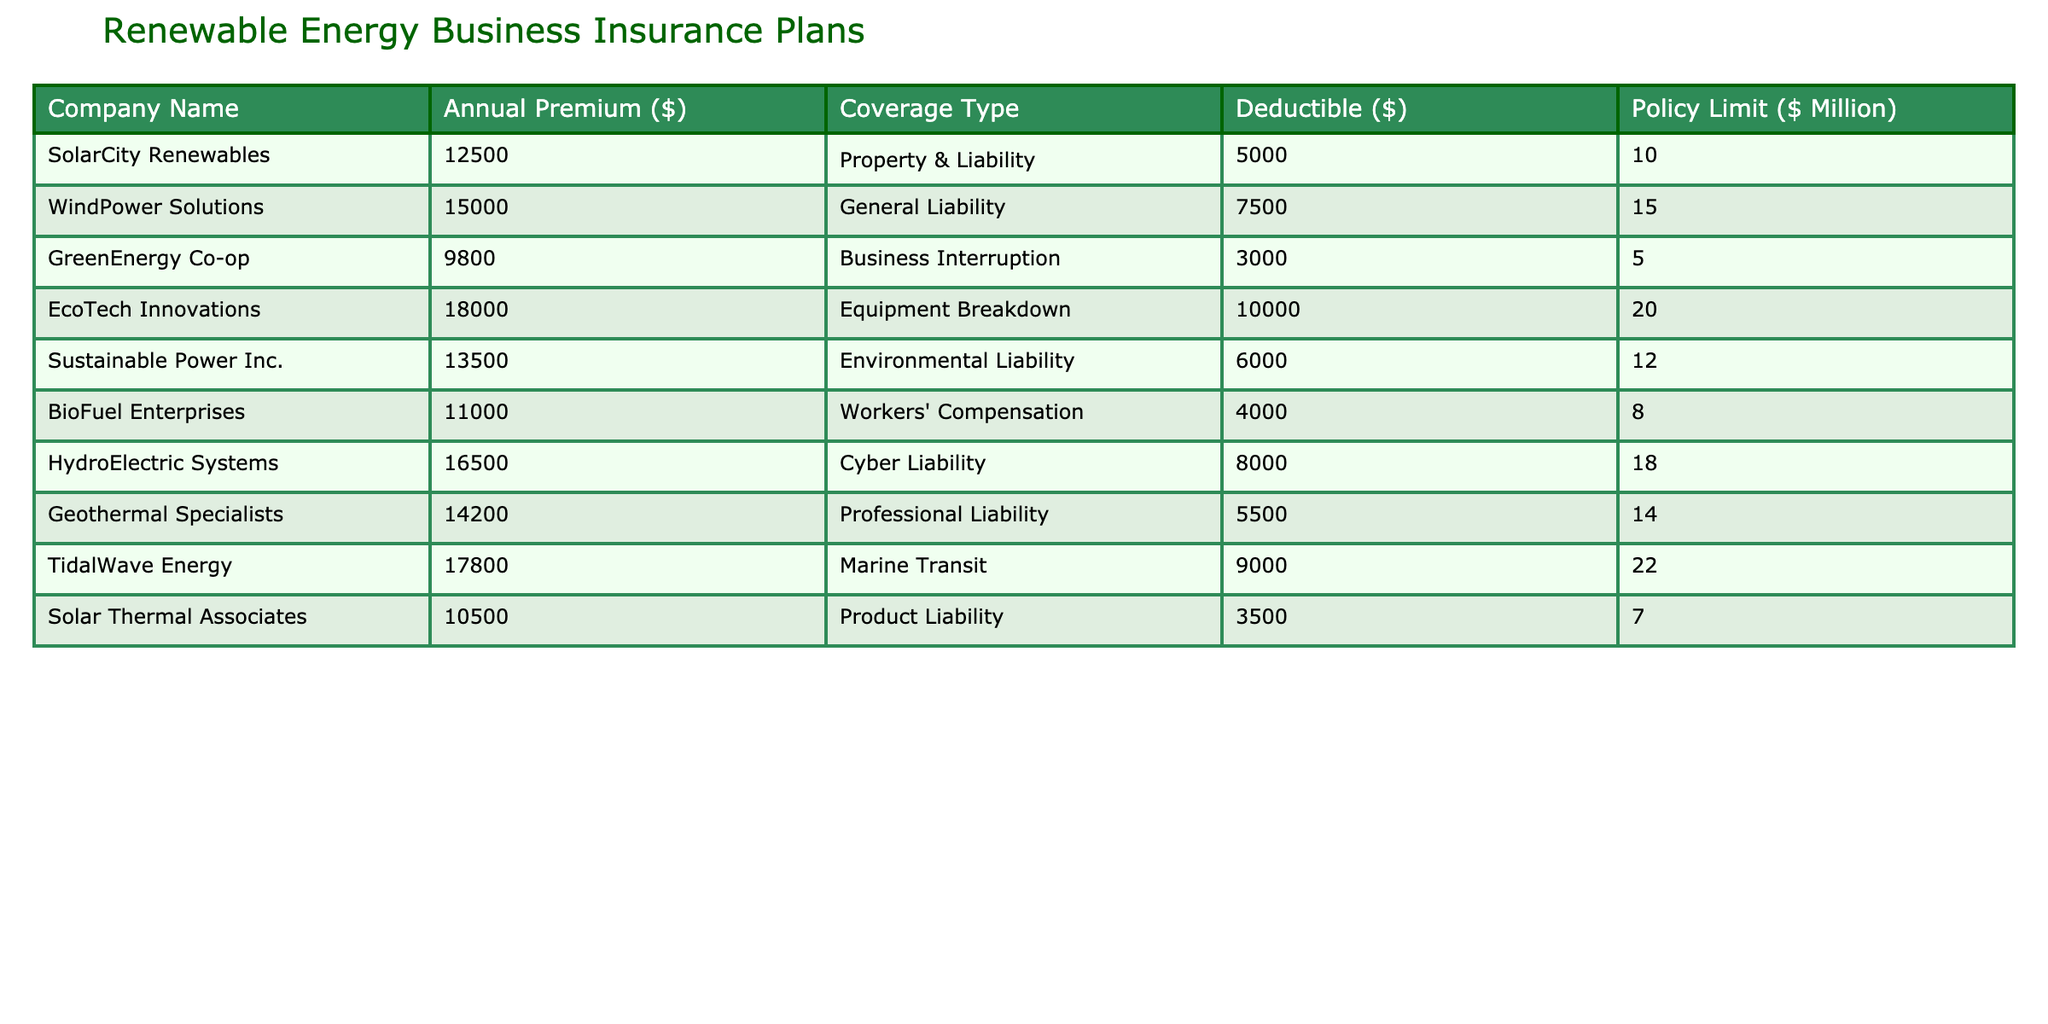What is the highest annual premium in the table? The highest annual premium can be found by scanning the "Annual Premium ($)" column. The value of $18,000 from EcoTech Innovations is the largest.
Answer: 18000 Which company has the lowest deductible? By inspecting the "Deductible ($)" column, the lowest deductible of $3,000 is assigned to GreenEnergy Co-op.
Answer: GreenEnergy Co-op What is the total policy limit of all the companies? Summing the "Policy Limit ($ Million)" for each company: 10 + 15 + 5 + 20 + 12 + 8 + 18 + 14 + 22 + 7 = 132 million dollars.
Answer: 132 million Is TidalWave Energy's premium higher than that of SolarCity Renewables? Comparing the premiums, TidalWave Energy's premium of $17,800 is indeed higher than SolarCity Renewables' premium of $12,500.
Answer: Yes What is the average premium cost across all companies? The total premium sum is $12,500 + $15,000 + $9,800 + $18,000 + $13,500 + $11,000 + $16,500 + $14,200 + $17,800 + $10,500 = $138,800. Dividing by 10 (the number of companies) gives the average premium of $13,880.
Answer: 13880 Which coverage type has the highest policy limit? Reviewing the “Policy Limit ($ Million)” column, Marine Transit under TidalWave Energy has the highest limit at $22 million.
Answer: Marine Transit Calculate the difference between the highest and lowest annual premiums. The highest premium is $18,000 (EcoTech Innovations), and the lowest is $9,800 (GreenEnergy Co-op). The difference is $18,000 - $9,800 = $8,200.
Answer: 8200 Do any companies offer more than $15 million in policy limit? Scanning the "Policy Limit ($ Million)" column, TidalWave Energy and EcoTech Innovations both offer over $15 million in policy limits, specifically $22 million and $20 million, respectively.
Answer: Yes How many companies have a deductible of $6,000 or lower? By examining the "Deductible ($)" column, the companies with $6,000 or lower deductibles are GreenEnergy Co-op ($3,000), BioFuel Enterprises ($4,000), and Sustainable Power Inc. ($6,000). There are three such companies.
Answer: 3 Which company provides coverage for Equipment Breakdown insurance? Equipment Breakdown insurance is specifically listed under EcoTech Innovations, according to the "Coverage Type" column.
Answer: EcoTech Innovations 